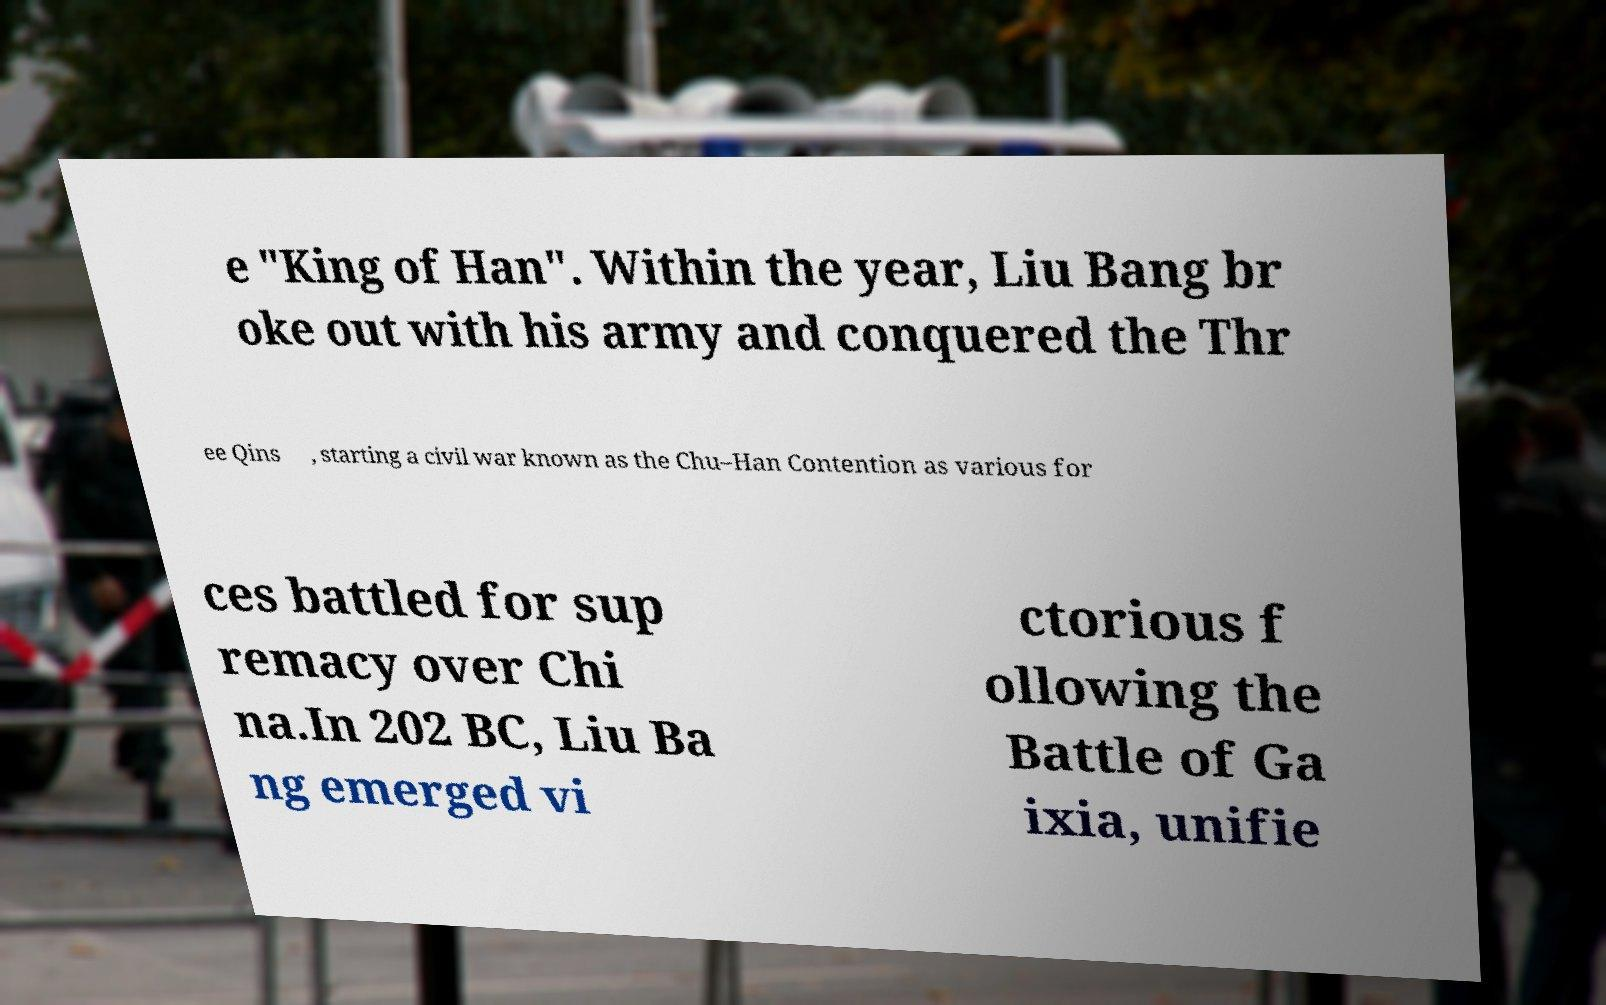Could you extract and type out the text from this image? e "King of Han". Within the year, Liu Bang br oke out with his army and conquered the Thr ee Qins , starting a civil war known as the Chu–Han Contention as various for ces battled for sup remacy over Chi na.In 202 BC, Liu Ba ng emerged vi ctorious f ollowing the Battle of Ga ixia, unifie 